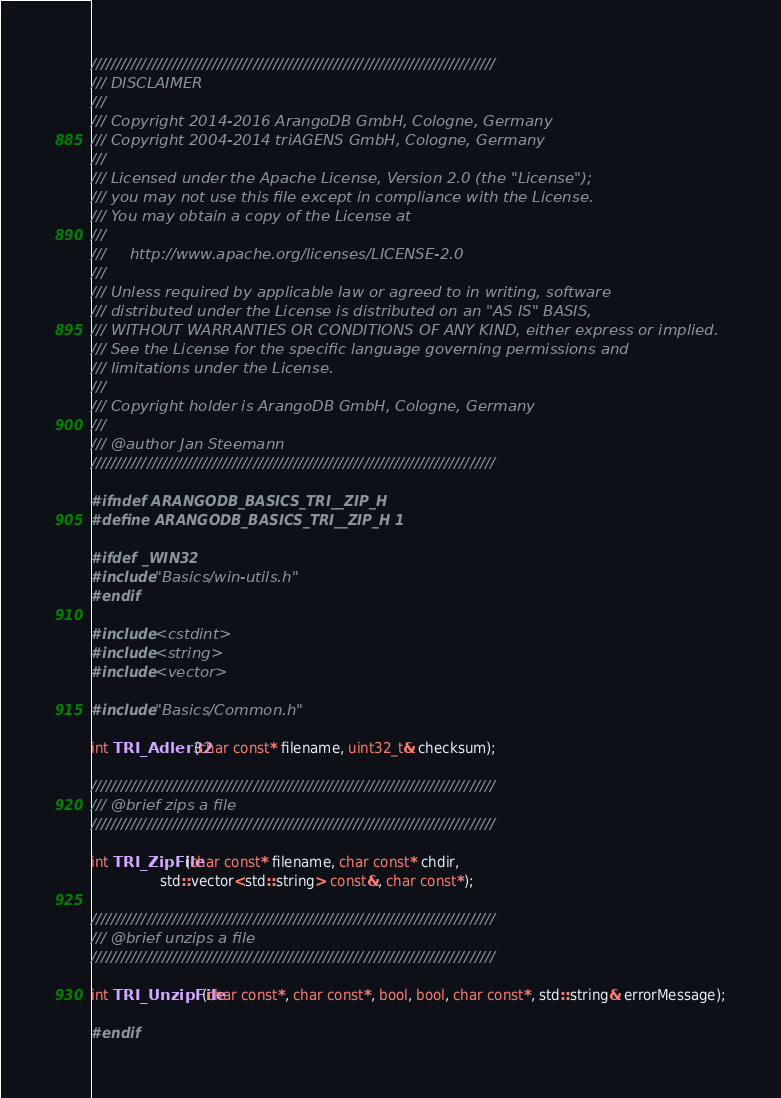<code> <loc_0><loc_0><loc_500><loc_500><_C_>////////////////////////////////////////////////////////////////////////////////
/// DISCLAIMER
///
/// Copyright 2014-2016 ArangoDB GmbH, Cologne, Germany
/// Copyright 2004-2014 triAGENS GmbH, Cologne, Germany
///
/// Licensed under the Apache License, Version 2.0 (the "License");
/// you may not use this file except in compliance with the License.
/// You may obtain a copy of the License at
///
///     http://www.apache.org/licenses/LICENSE-2.0
///
/// Unless required by applicable law or agreed to in writing, software
/// distributed under the License is distributed on an "AS IS" BASIS,
/// WITHOUT WARRANTIES OR CONDITIONS OF ANY KIND, either express or implied.
/// See the License for the specific language governing permissions and
/// limitations under the License.
///
/// Copyright holder is ArangoDB GmbH, Cologne, Germany
///
/// @author Jan Steemann
////////////////////////////////////////////////////////////////////////////////

#ifndef ARANGODB_BASICS_TRI__ZIP_H
#define ARANGODB_BASICS_TRI__ZIP_H 1

#ifdef _WIN32
#include "Basics/win-utils.h"
#endif

#include <cstdint>
#include <string>
#include <vector>

#include "Basics/Common.h"

int TRI_Adler32(char const* filename, uint32_t& checksum);

////////////////////////////////////////////////////////////////////////////////
/// @brief zips a file
////////////////////////////////////////////////////////////////////////////////

int TRI_ZipFile(char const* filename, char const* chdir,
                std::vector<std::string> const&, char const*);

////////////////////////////////////////////////////////////////////////////////
/// @brief unzips a file
////////////////////////////////////////////////////////////////////////////////

int TRI_UnzipFile(char const*, char const*, bool, bool, char const*, std::string& errorMessage);

#endif
</code> 